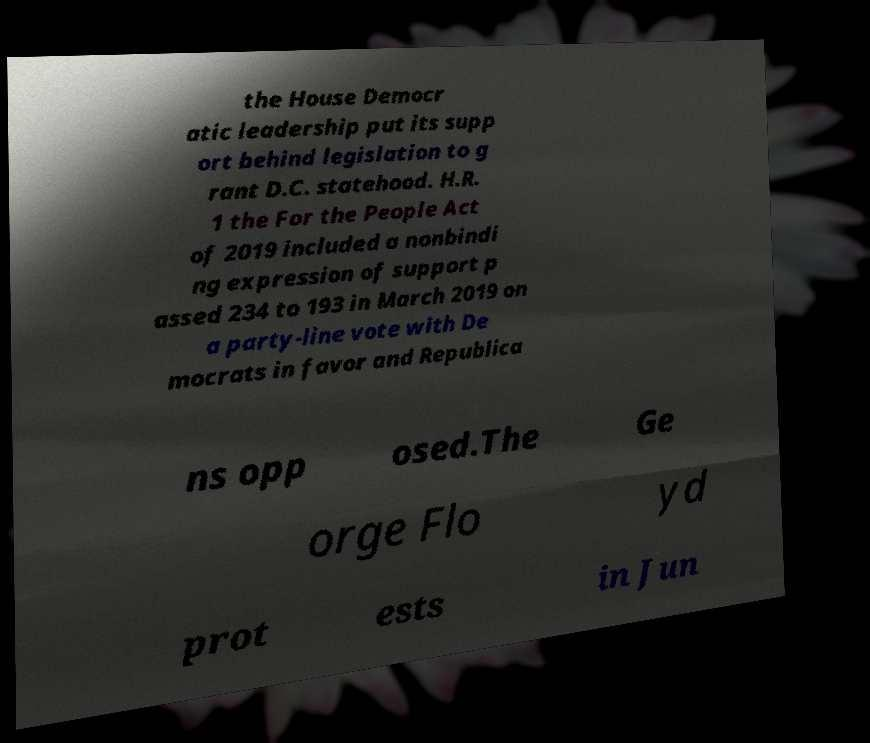Please identify and transcribe the text found in this image. the House Democr atic leadership put its supp ort behind legislation to g rant D.C. statehood. H.R. 1 the For the People Act of 2019 included a nonbindi ng expression of support p assed 234 to 193 in March 2019 on a party-line vote with De mocrats in favor and Republica ns opp osed.The Ge orge Flo yd prot ests in Jun 